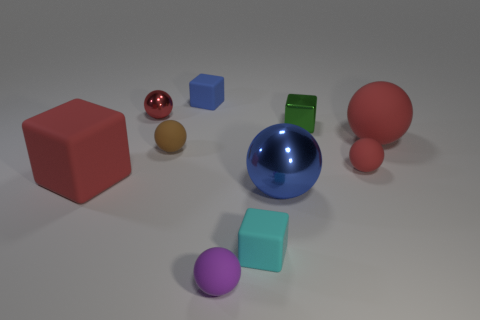Subtract all red spheres. How many were subtracted if there are1red spheres left? 2 Add 6 tiny purple objects. How many tiny purple objects exist? 7 Subtract all purple spheres. How many spheres are left? 5 Subtract all large red matte blocks. How many blocks are left? 3 Subtract 1 purple balls. How many objects are left? 9 Subtract all spheres. How many objects are left? 4 Subtract 1 spheres. How many spheres are left? 5 Subtract all yellow blocks. Subtract all red cylinders. How many blocks are left? 4 Subtract all green balls. How many cyan blocks are left? 1 Subtract all small blue matte cubes. Subtract all small blue matte objects. How many objects are left? 8 